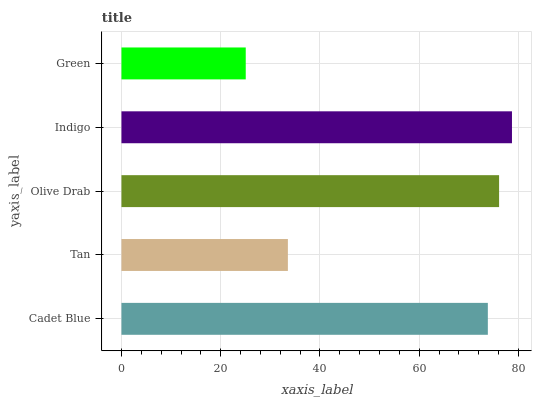Is Green the minimum?
Answer yes or no. Yes. Is Indigo the maximum?
Answer yes or no. Yes. Is Tan the minimum?
Answer yes or no. No. Is Tan the maximum?
Answer yes or no. No. Is Cadet Blue greater than Tan?
Answer yes or no. Yes. Is Tan less than Cadet Blue?
Answer yes or no. Yes. Is Tan greater than Cadet Blue?
Answer yes or no. No. Is Cadet Blue less than Tan?
Answer yes or no. No. Is Cadet Blue the high median?
Answer yes or no. Yes. Is Cadet Blue the low median?
Answer yes or no. Yes. Is Indigo the high median?
Answer yes or no. No. Is Olive Drab the low median?
Answer yes or no. No. 